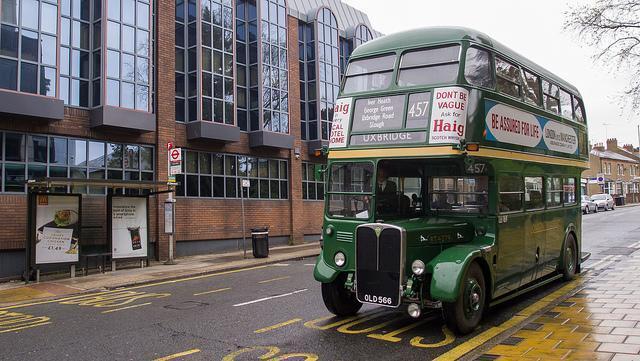What type of infrastructure does this city avoid having?
Select the accurate response from the four choices given to answer the question.
Options: Low overpasses, sidewalks, aqueducts, bridges. Low overpasses. 